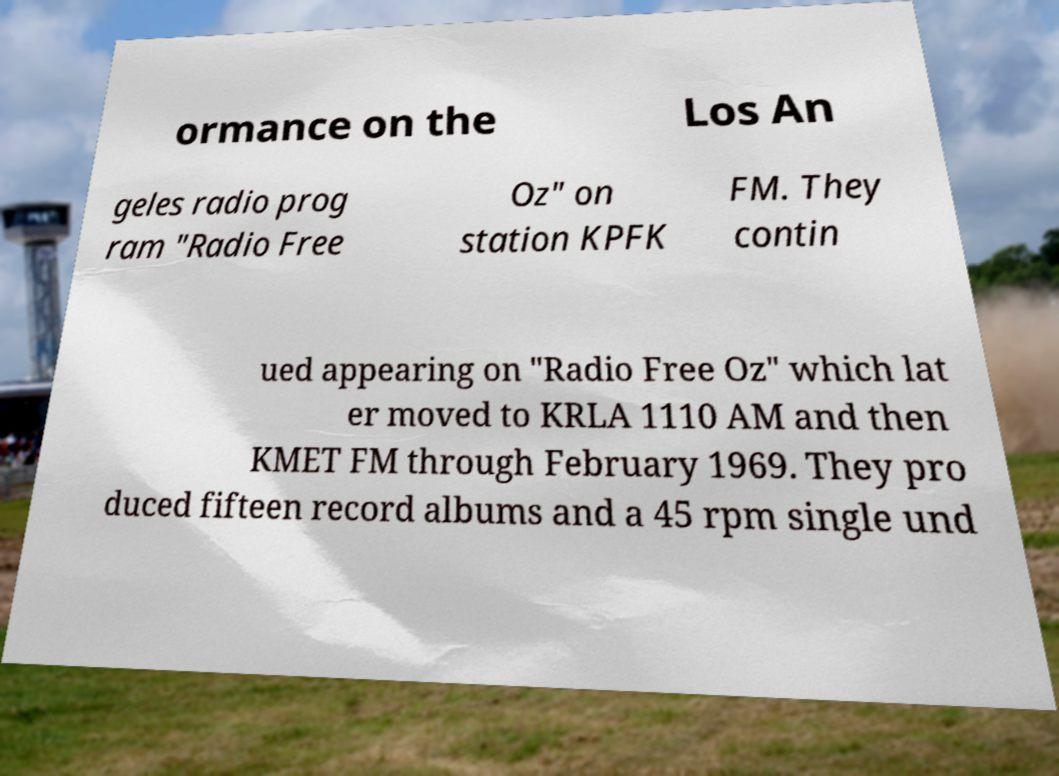Can you read and provide the text displayed in the image?This photo seems to have some interesting text. Can you extract and type it out for me? ormance on the Los An geles radio prog ram "Radio Free Oz" on station KPFK FM. They contin ued appearing on "Radio Free Oz" which lat er moved to KRLA 1110 AM and then KMET FM through February 1969. They pro duced fifteen record albums and a 45 rpm single und 